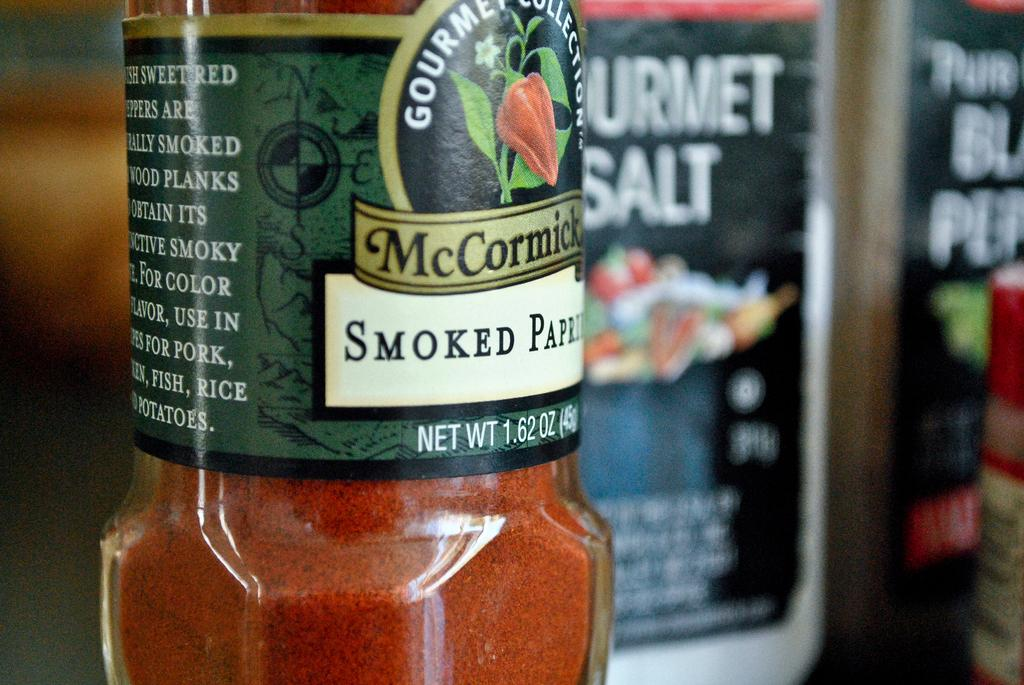<image>
Create a compact narrative representing the image presented. Mccormick smoked paprika seasoning that is a gourmet collection 